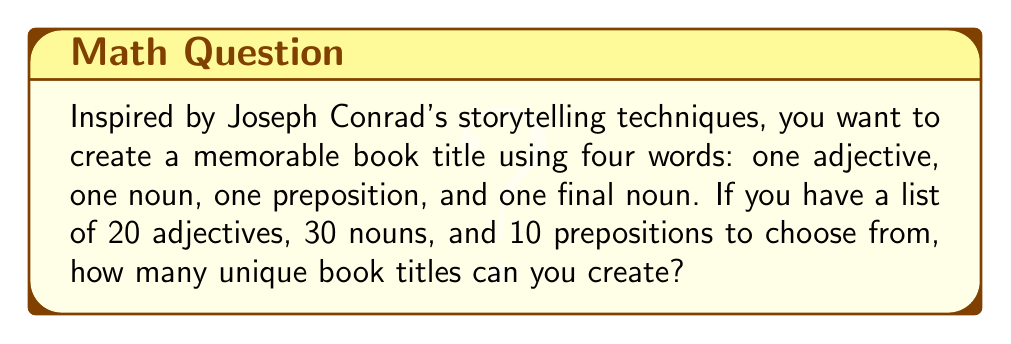Show me your answer to this math problem. Let's approach this step-by-step using the fundamental counting principle:

1) For the first word (adjective), we have 20 choices.

2) For the second word (noun), we have 30 choices.

3) For the third word (preposition), we have 10 choices.

4) For the fourth word (noun), we have 29 choices. We use 29 instead of 30 because we assume we don't want to repeat the same noun used in the second position.

5) According to the fundamental counting principle, if we have a series of choices where we have $m$ ways of doing something, $n$ ways of doing another thing, $p$ ways of doing a third thing, and so on, then there are $m \times n \times p \times ...$ ways to do the entire series of things.

6) Therefore, the total number of unique book titles is:

   $$ 20 \times 30 \times 10 \times 29 = 174,000 $$

This calculation gives us the total number of possible word combinations for creating a memorable book title using the given constraints.
Answer: 174,000 